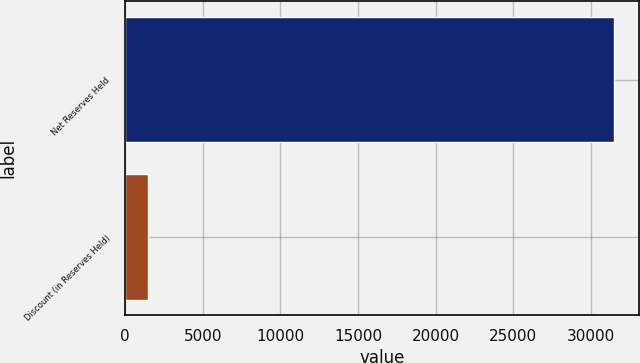Convert chart to OTSL. <chart><loc_0><loc_0><loc_500><loc_500><bar_chart><fcel>Net Reserves Held<fcel>Discount (in Reserves Held)<nl><fcel>31515<fcel>1499<nl></chart> 